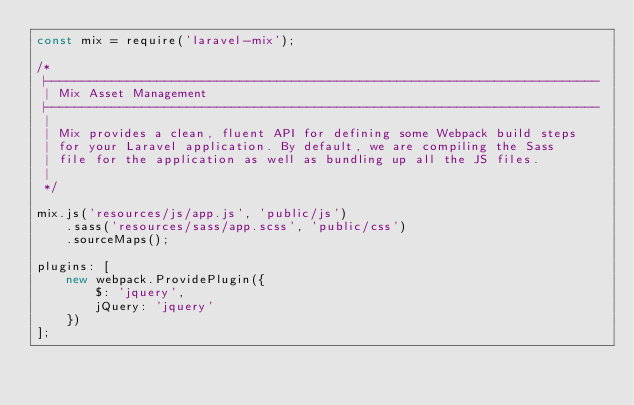Convert code to text. <code><loc_0><loc_0><loc_500><loc_500><_JavaScript_>const mix = require('laravel-mix');

/*
 |--------------------------------------------------------------------------
 | Mix Asset Management
 |--------------------------------------------------------------------------
 |
 | Mix provides a clean, fluent API for defining some Webpack build steps
 | for your Laravel application. By default, we are compiling the Sass
 | file for the application as well as bundling up all the JS files.
 |
 */

mix.js('resources/js/app.js', 'public/js')
    .sass('resources/sass/app.scss', 'public/css')
    .sourceMaps();

plugins: [
    new webpack.ProvidePlugin({
        $: 'jquery',
        jQuery: 'jquery'
    })
];
</code> 